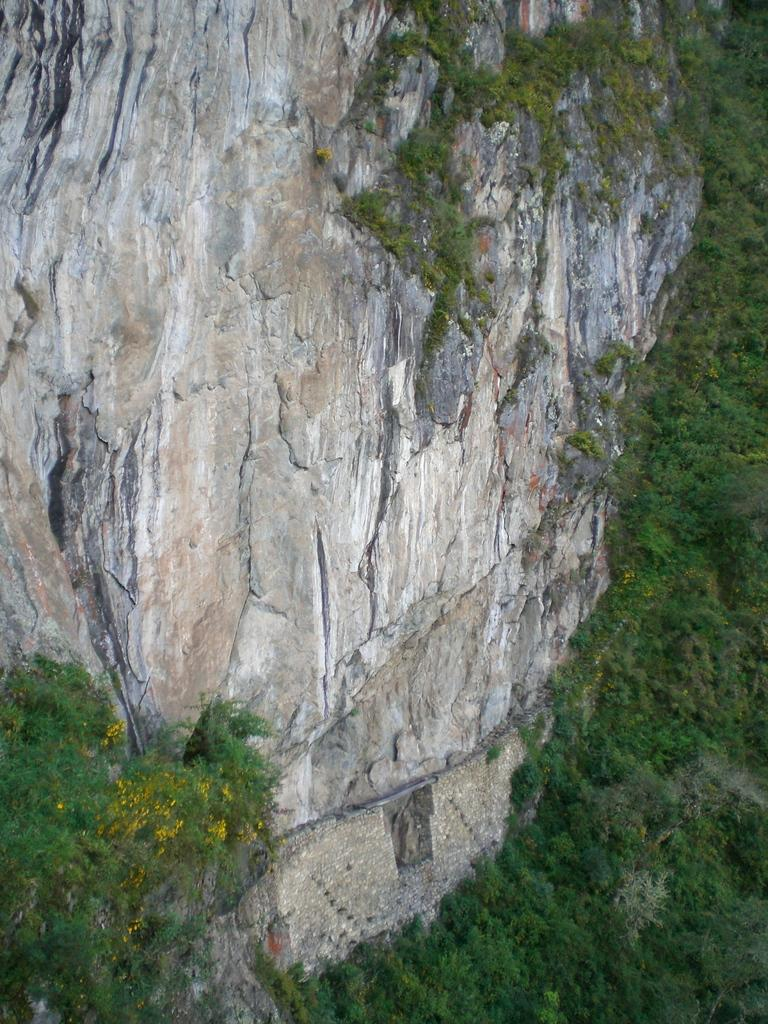What is located on the rock in the image? There are plants on a rock in the image. What type of knot can be seen tied around the plants in the image? There is no knot present in the image; it features plants on a rock. Why are the plants crying in the image? Plants do not have the ability to cry, and there is no indication of any emotional state in the image. 